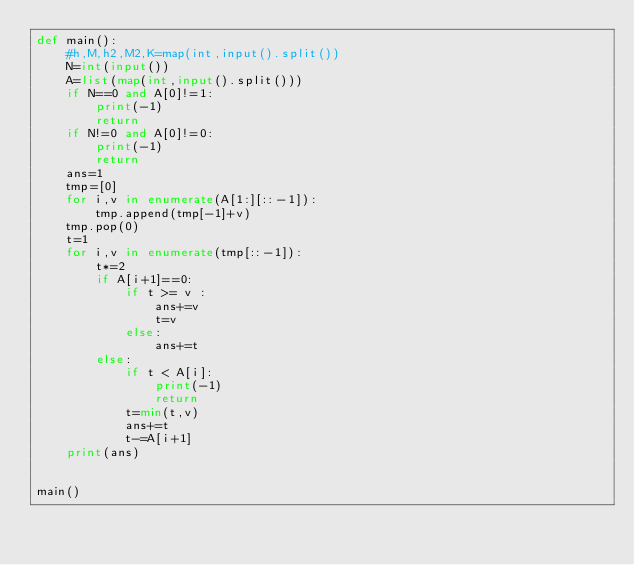<code> <loc_0><loc_0><loc_500><loc_500><_Python_>def main():
    #h,M,h2,M2,K=map(int,input().split())
    N=int(input())
    A=list(map(int,input().split()))
    if N==0 and A[0]!=1:
        print(-1)
        return 
    if N!=0 and A[0]!=0:
        print(-1)
        return 
    ans=1
    tmp=[0]
    for i,v in enumerate(A[1:][::-1]):
        tmp.append(tmp[-1]+v)
    tmp.pop(0)
    t=1
    for i,v in enumerate(tmp[::-1]):
        t*=2
        if A[i+1]==0:
            if t >= v :
                ans+=v
                t=v
            else:
                ans+=t
        else:
            if t < A[i]:
                print(-1)
                return
            t=min(t,v)
            ans+=t
            t-=A[i+1]
    print(ans)


main()</code> 